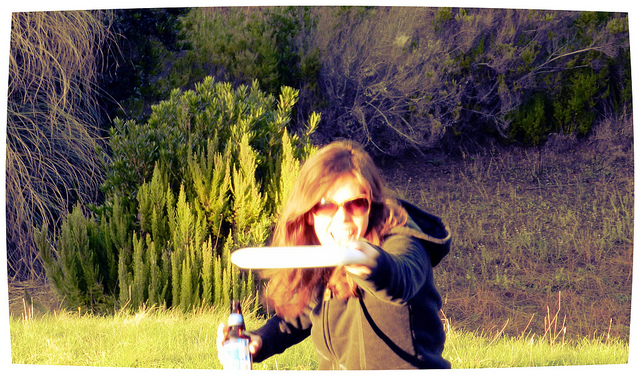<image>Why is the bottle not made of clear glass? I don't know why the bottle is not made of clear glass. It may be a beer bottle, made of plastic, or designed to keep out light for safety reasons. Why is the bottle not made of clear glass? I don't know why the bottle is not made of clear glass. It can be because it is a beer bottle or made of plastic. 